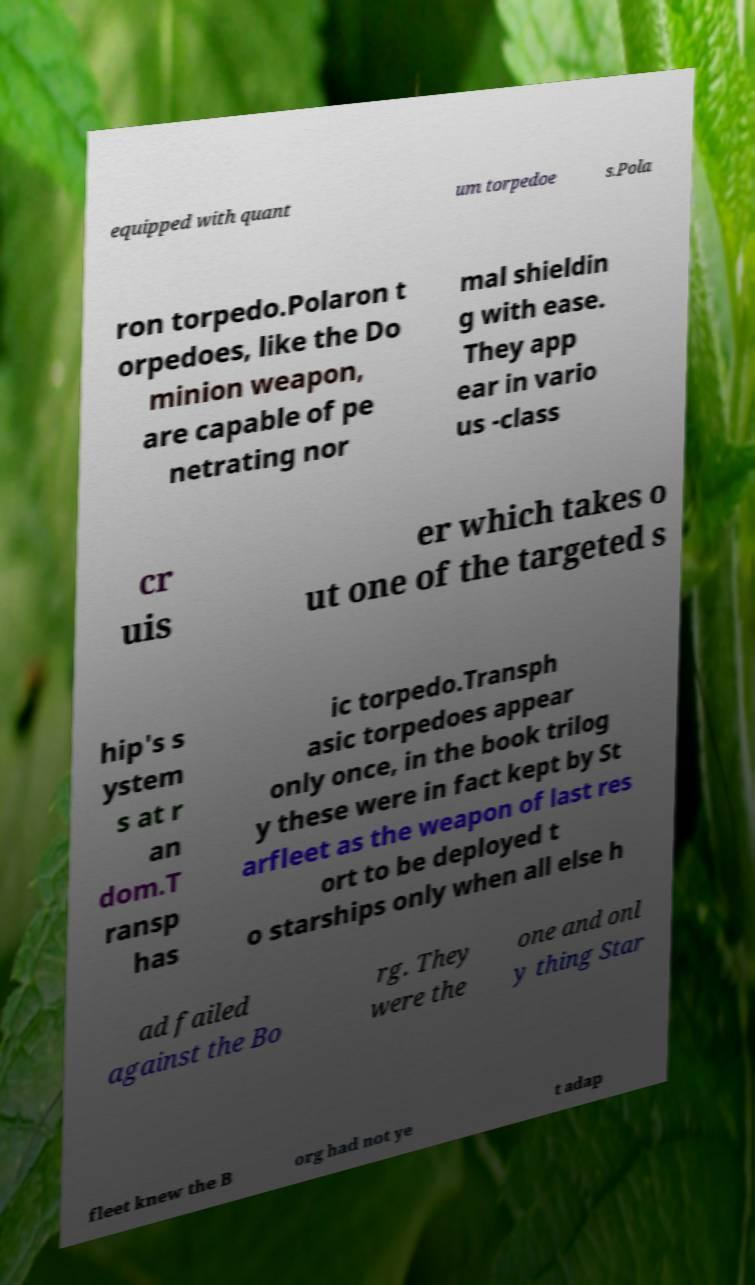Can you accurately transcribe the text from the provided image for me? equipped with quant um torpedoe s.Pola ron torpedo.Polaron t orpedoes, like the Do minion weapon, are capable of pe netrating nor mal shieldin g with ease. They app ear in vario us -class cr uis er which takes o ut one of the targeted s hip's s ystem s at r an dom.T ransp has ic torpedo.Transph asic torpedoes appear only once, in the book trilog y these were in fact kept by St arfleet as the weapon of last res ort to be deployed t o starships only when all else h ad failed against the Bo rg. They were the one and onl y thing Star fleet knew the B org had not ye t adap 